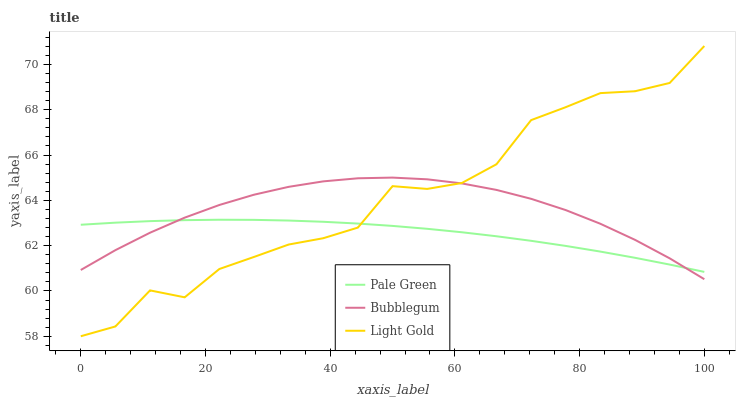Does Pale Green have the minimum area under the curve?
Answer yes or no. Yes. Does Light Gold have the maximum area under the curve?
Answer yes or no. Yes. Does Bubblegum have the minimum area under the curve?
Answer yes or no. No. Does Bubblegum have the maximum area under the curve?
Answer yes or no. No. Is Pale Green the smoothest?
Answer yes or no. Yes. Is Light Gold the roughest?
Answer yes or no. Yes. Is Bubblegum the smoothest?
Answer yes or no. No. Is Bubblegum the roughest?
Answer yes or no. No. Does Light Gold have the lowest value?
Answer yes or no. Yes. Does Bubblegum have the lowest value?
Answer yes or no. No. Does Light Gold have the highest value?
Answer yes or no. Yes. Does Bubblegum have the highest value?
Answer yes or no. No. Does Pale Green intersect Bubblegum?
Answer yes or no. Yes. Is Pale Green less than Bubblegum?
Answer yes or no. No. Is Pale Green greater than Bubblegum?
Answer yes or no. No. 